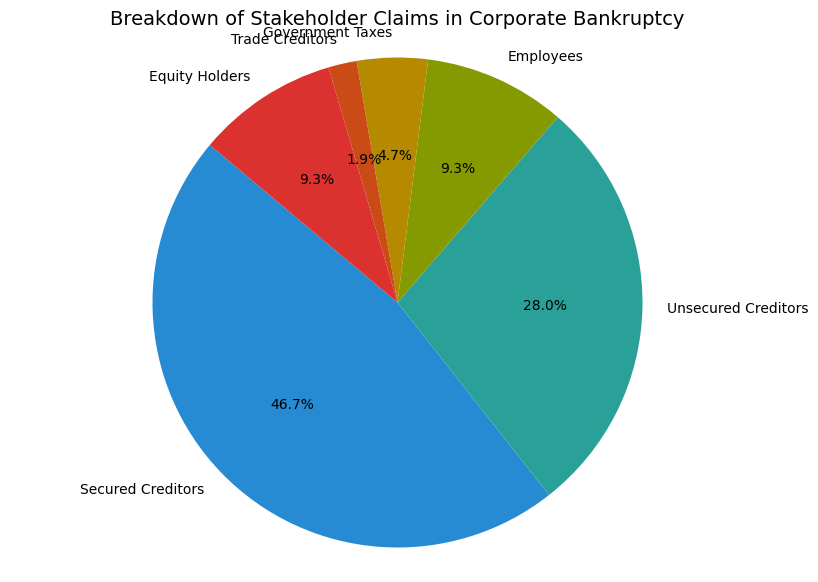Which stakeholder has the largest claim? The pie chart shows several segments, and the segment labeled "Secured Creditors" occupies the largest portion of the pie.
Answer: Secured Creditors What percentage of the total is claimed by the unsecured creditors? The pie chart labels the "Unsecured Creditors" segment with its percentage. It shows 30.0%.
Answer: 30.0% What is the combined percentage of the claims by employees and equity holders? The pie chart shows the percentage for employees and equity holders individually as 10% each. 10% + 10% = 20%.
Answer: 20% Among Government Taxes and Trade Creditors, who has the smaller claim, and by what percentage is it smaller? The pie chart shows that Government Taxes have 5.0% and Trade Creditors have 2.0%. By subtracting, 5.0% - 2.0% = 3.0%.
Answer: Trade Creditors, 3.0% What is the total claim percentage for all groups excluding Secured Creditors? The pie chart gives the percentages for each segment: Unsecured Creditors (30.0%), Employees (10.0%), Government Taxes (5.0%), Trade Creditors (2.0%), Equity Holders (10.0%). Adding these gives 30.0% + 10.0% + 5.0% + 2.0% + 10.0% = 57.0%.
Answer: 57.0% By how much is the claim of Secured Creditors greater than that of Equity Holders? The pie chart shows that Secured Creditors hold 50.0% and Equity Holders hold 10.0%. The difference is 50.0% - 10.0% = 40.0%.
Answer: 40.0% If the total value of claims is $10,000,000, what is the amount claimed by Government Taxes? Government Taxes are 5.0% of the total claims. 5.0% of $10,000,000 is calculated as $10,000,000 * 0.05 = $500,000.
Answer: $500,000 Which stakeholder has a claim greater than the combined claims of Government Taxes and Trade Creditors? Government Taxes and Trade Creditors together claim 5.0% + 2.0% = 7.0%. Each of Secured Creditors (50.0%), Unsecured Creditors (30.0%), Employees (10.0%), and Equity Holders (10.0%) have claims greater than 7.0%.
Answer: Secured Creditors, Unsecured Creditors, Employees, Equity Holders What is the difference in percentage points between the claims of Unsecured Creditors and Employees? The pie chart shows Unsecured Creditors at 30.0% and Employees at 10.0%; the difference is 30.0% - 10.0% = 20.0%.
Answer: 20.0% 